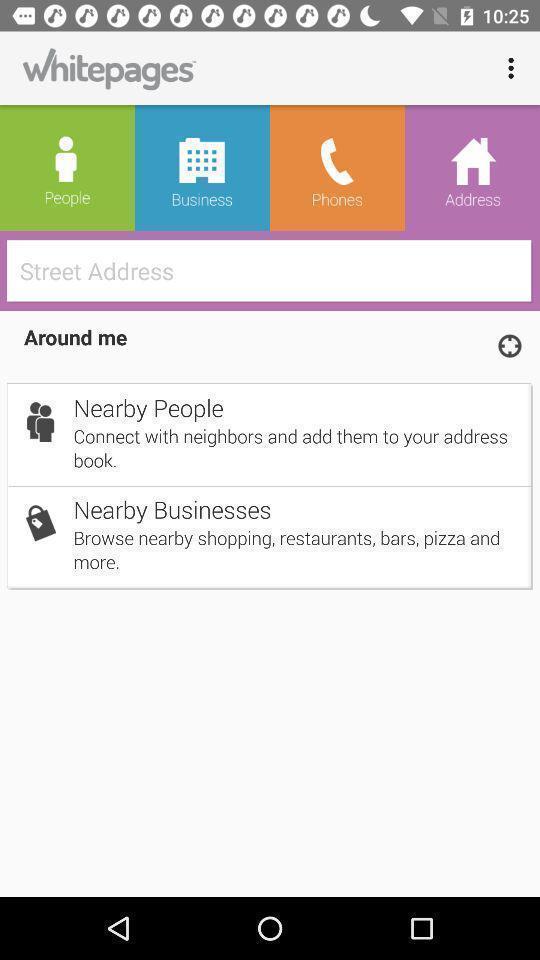What is the overall content of this screenshot? Page displaying to find street address near by in application. 